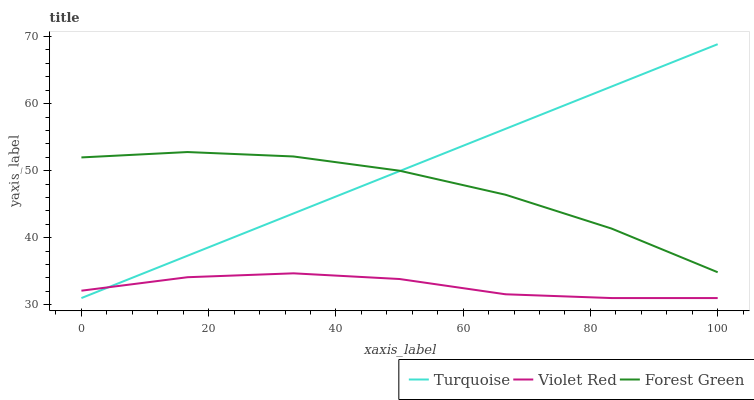Does Violet Red have the minimum area under the curve?
Answer yes or no. Yes. Does Turquoise have the maximum area under the curve?
Answer yes or no. Yes. Does Turquoise have the minimum area under the curve?
Answer yes or no. No. Does Violet Red have the maximum area under the curve?
Answer yes or no. No. Is Turquoise the smoothest?
Answer yes or no. Yes. Is Forest Green the roughest?
Answer yes or no. Yes. Is Violet Red the smoothest?
Answer yes or no. No. Is Violet Red the roughest?
Answer yes or no. No. Does Turquoise have the lowest value?
Answer yes or no. Yes. Does Turquoise have the highest value?
Answer yes or no. Yes. Does Violet Red have the highest value?
Answer yes or no. No. Is Violet Red less than Forest Green?
Answer yes or no. Yes. Is Forest Green greater than Violet Red?
Answer yes or no. Yes. Does Turquoise intersect Forest Green?
Answer yes or no. Yes. Is Turquoise less than Forest Green?
Answer yes or no. No. Is Turquoise greater than Forest Green?
Answer yes or no. No. Does Violet Red intersect Forest Green?
Answer yes or no. No. 